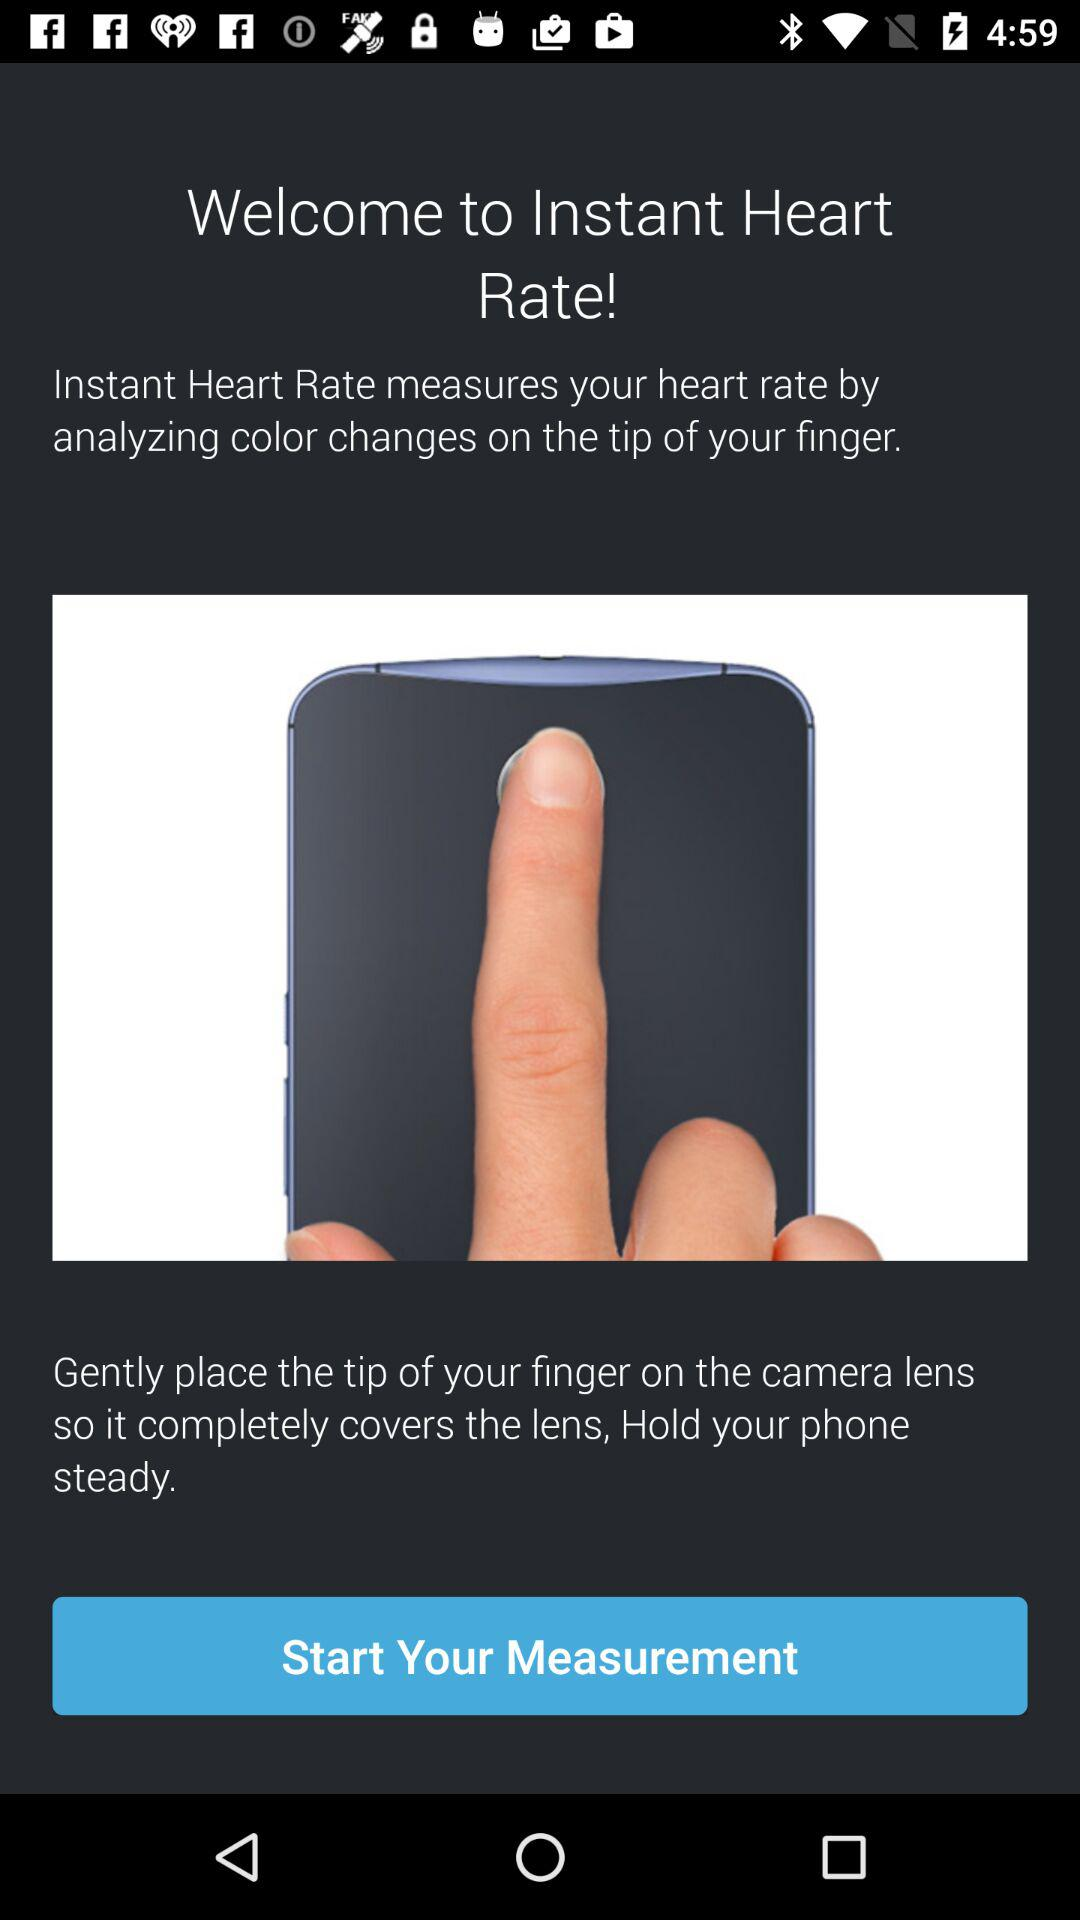What is the application name? The application name is "Instant Heart Rate". 